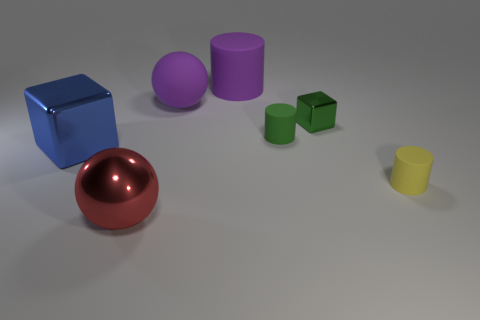Subtract all tiny green matte cylinders. How many cylinders are left? 2 Add 2 small green metallic objects. How many objects exist? 9 Subtract all cyan cylinders. Subtract all cyan cubes. How many cylinders are left? 3 Subtract all cylinders. How many objects are left? 4 Subtract all tiny cyan rubber things. Subtract all tiny yellow things. How many objects are left? 6 Add 4 metallic things. How many metallic things are left? 7 Add 7 big blue shiny blocks. How many big blue shiny blocks exist? 8 Subtract 0 yellow blocks. How many objects are left? 7 